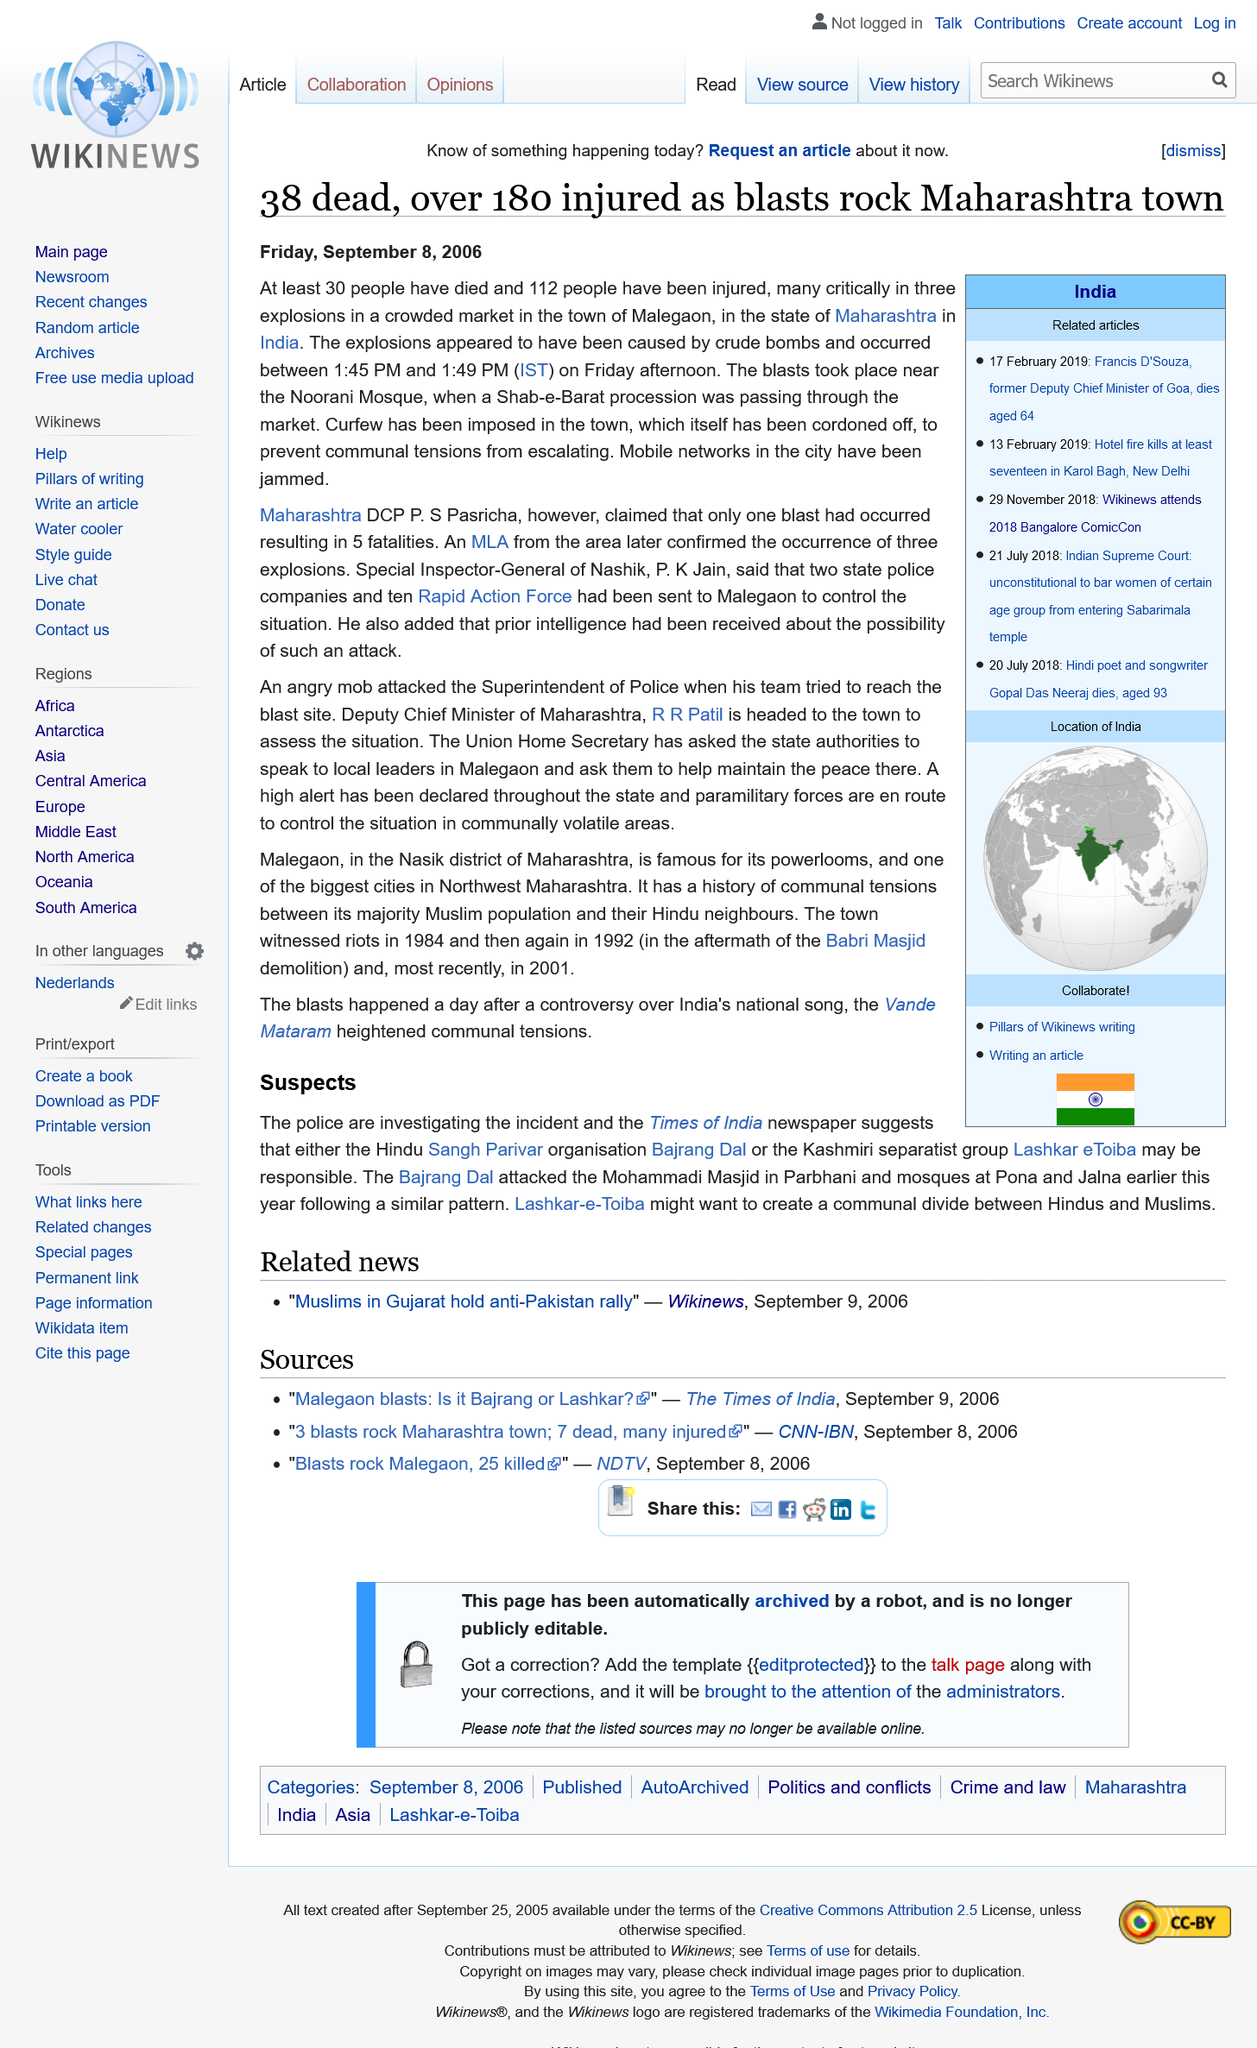Give some essential details in this illustration. The explosions occurred between 1:45 PM and 1:49 PM (IST). At least 30 people have died in the explosion. The blasts occurred in the state of Maharashtra near Noorani Mosque. 